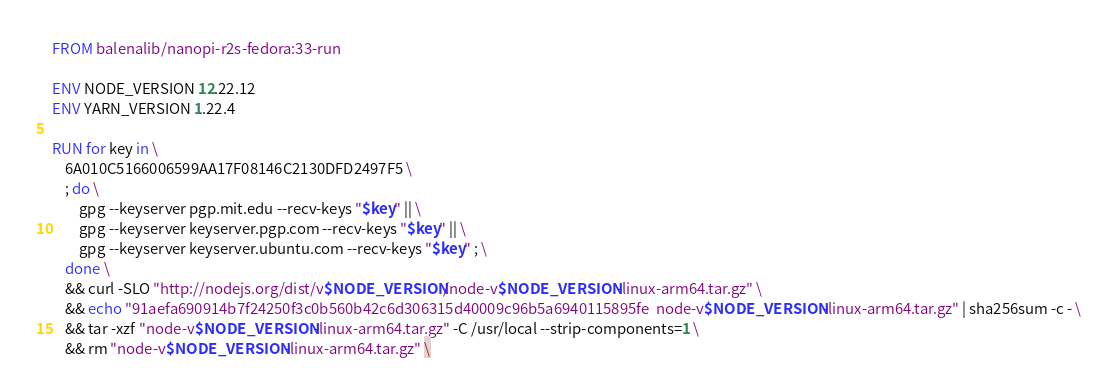Convert code to text. <code><loc_0><loc_0><loc_500><loc_500><_Dockerfile_>FROM balenalib/nanopi-r2s-fedora:33-run

ENV NODE_VERSION 12.22.12
ENV YARN_VERSION 1.22.4

RUN for key in \
	6A010C5166006599AA17F08146C2130DFD2497F5 \
	; do \
		gpg --keyserver pgp.mit.edu --recv-keys "$key" || \
		gpg --keyserver keyserver.pgp.com --recv-keys "$key" || \
		gpg --keyserver keyserver.ubuntu.com --recv-keys "$key" ; \
	done \
	&& curl -SLO "http://nodejs.org/dist/v$NODE_VERSION/node-v$NODE_VERSION-linux-arm64.tar.gz" \
	&& echo "91aefa690914b7f24250f3c0b560b42c6d306315d40009c96b5a6940115895fe  node-v$NODE_VERSION-linux-arm64.tar.gz" | sha256sum -c - \
	&& tar -xzf "node-v$NODE_VERSION-linux-arm64.tar.gz" -C /usr/local --strip-components=1 \
	&& rm "node-v$NODE_VERSION-linux-arm64.tar.gz" \</code> 